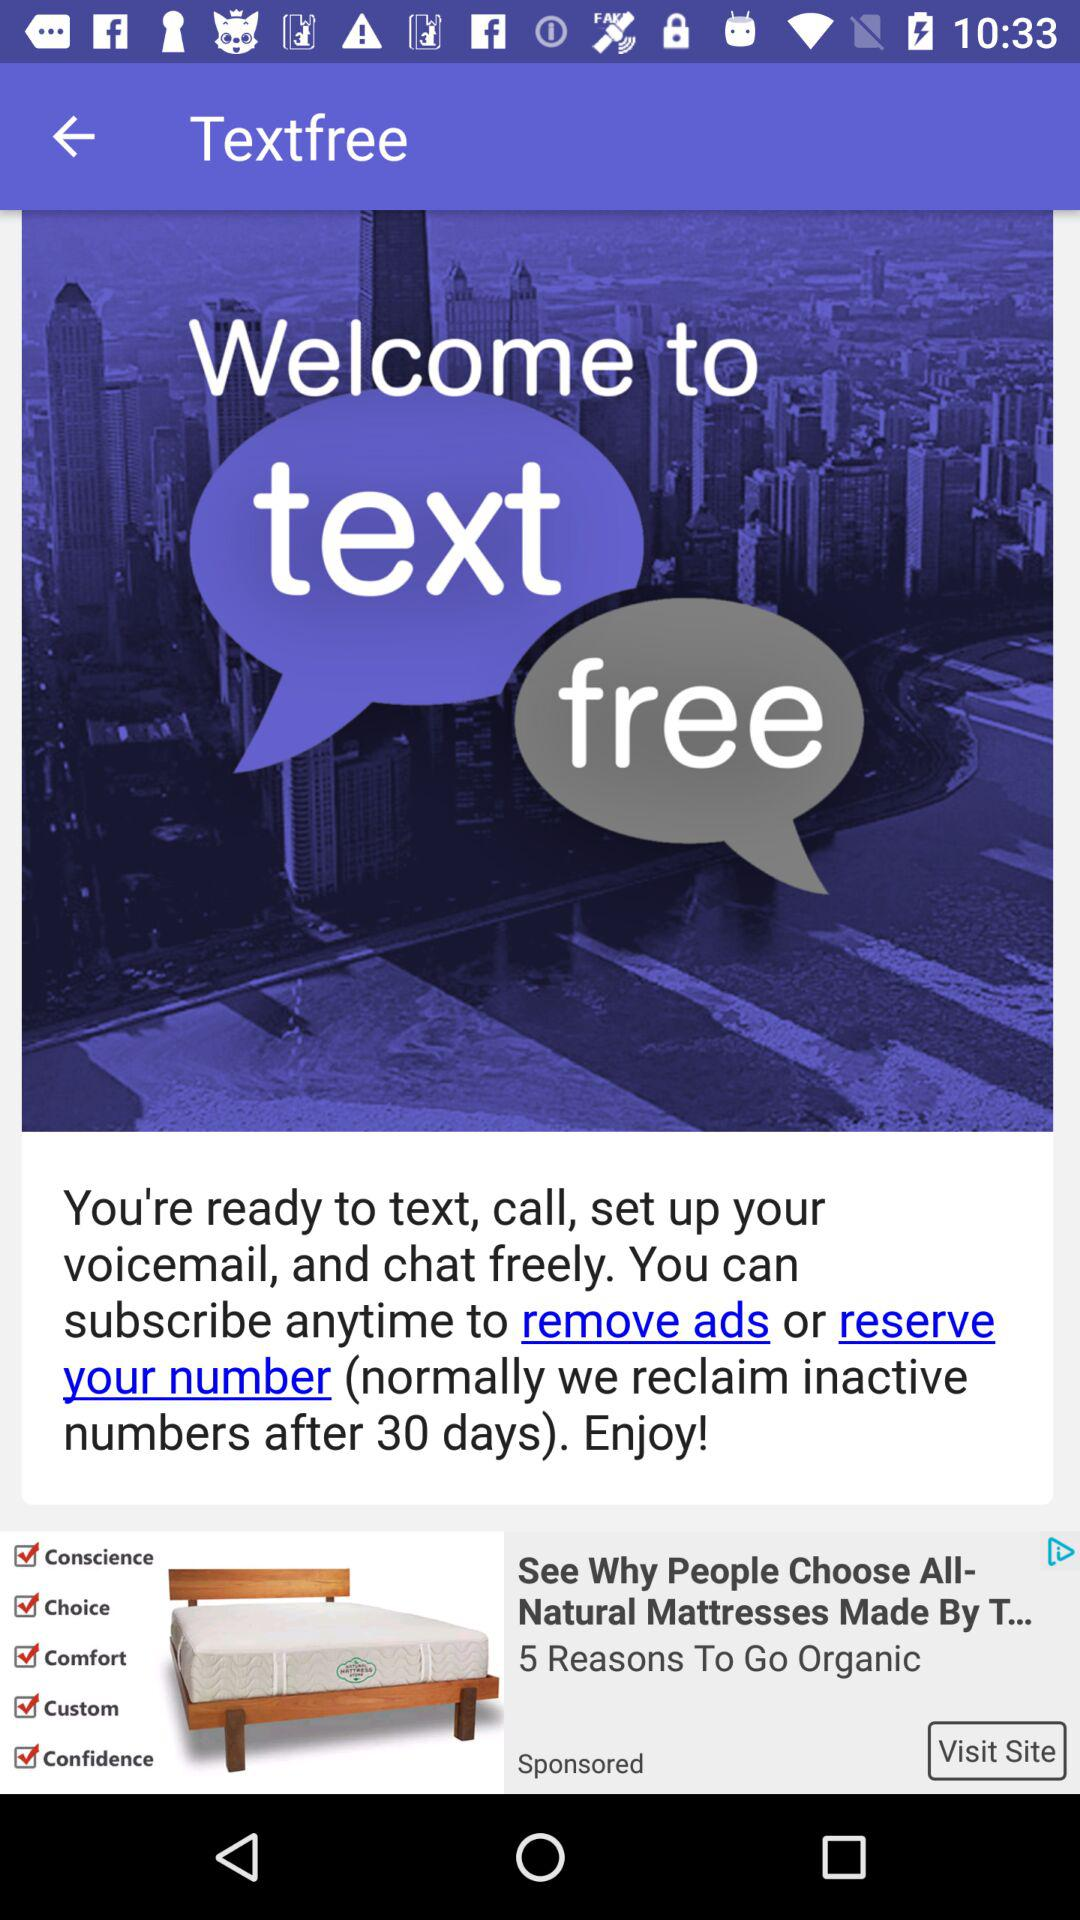After how many days can we reclaim inactive numbers? We can reclaim inactive numbers after 30 days. 